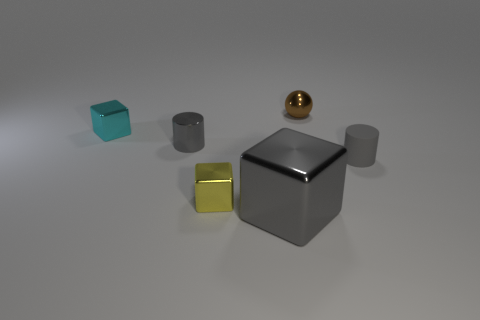Add 4 tiny gray objects. How many objects exist? 10 Subtract all spheres. How many objects are left? 5 Add 6 large things. How many large things exist? 7 Subtract 1 brown balls. How many objects are left? 5 Subtract all big things. Subtract all cylinders. How many objects are left? 3 Add 2 tiny yellow metal cubes. How many tiny yellow metal cubes are left? 3 